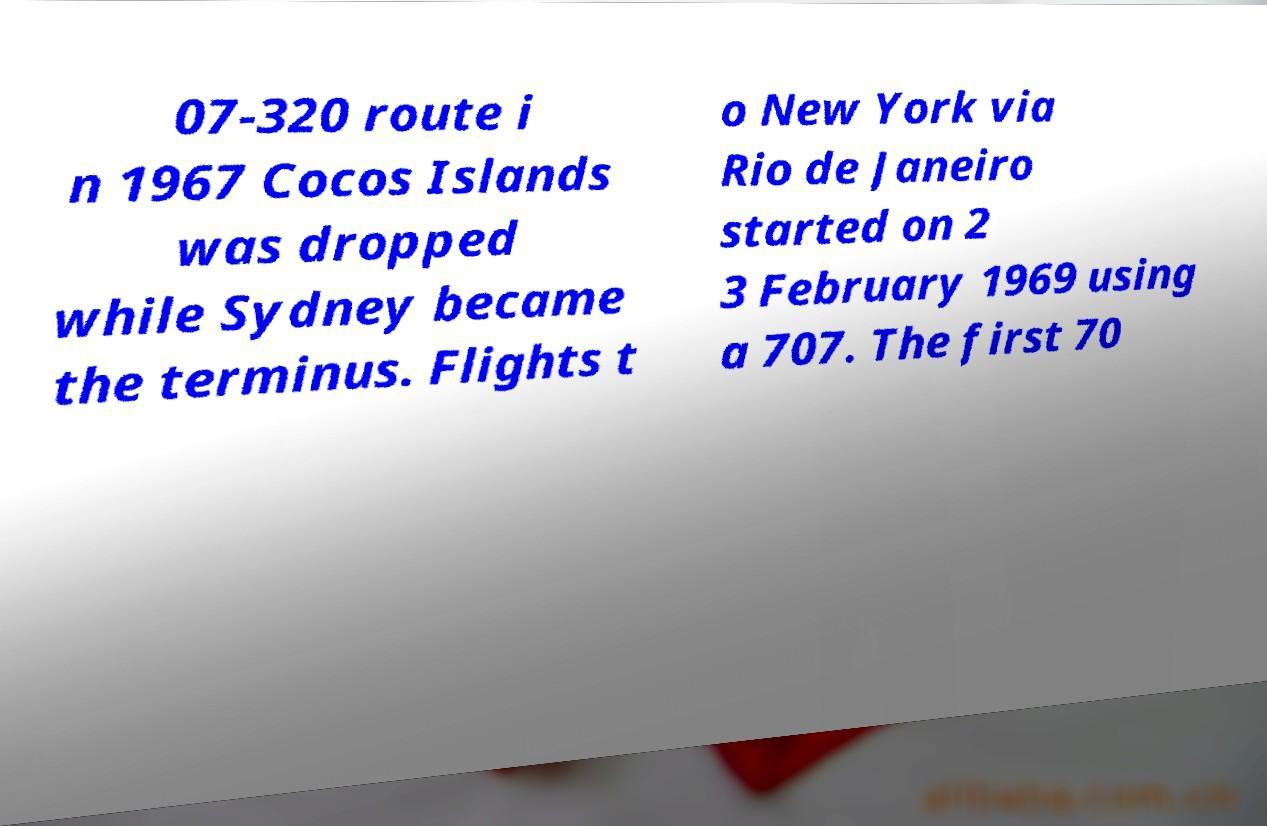There's text embedded in this image that I need extracted. Can you transcribe it verbatim? 07-320 route i n 1967 Cocos Islands was dropped while Sydney became the terminus. Flights t o New York via Rio de Janeiro started on 2 3 February 1969 using a 707. The first 70 